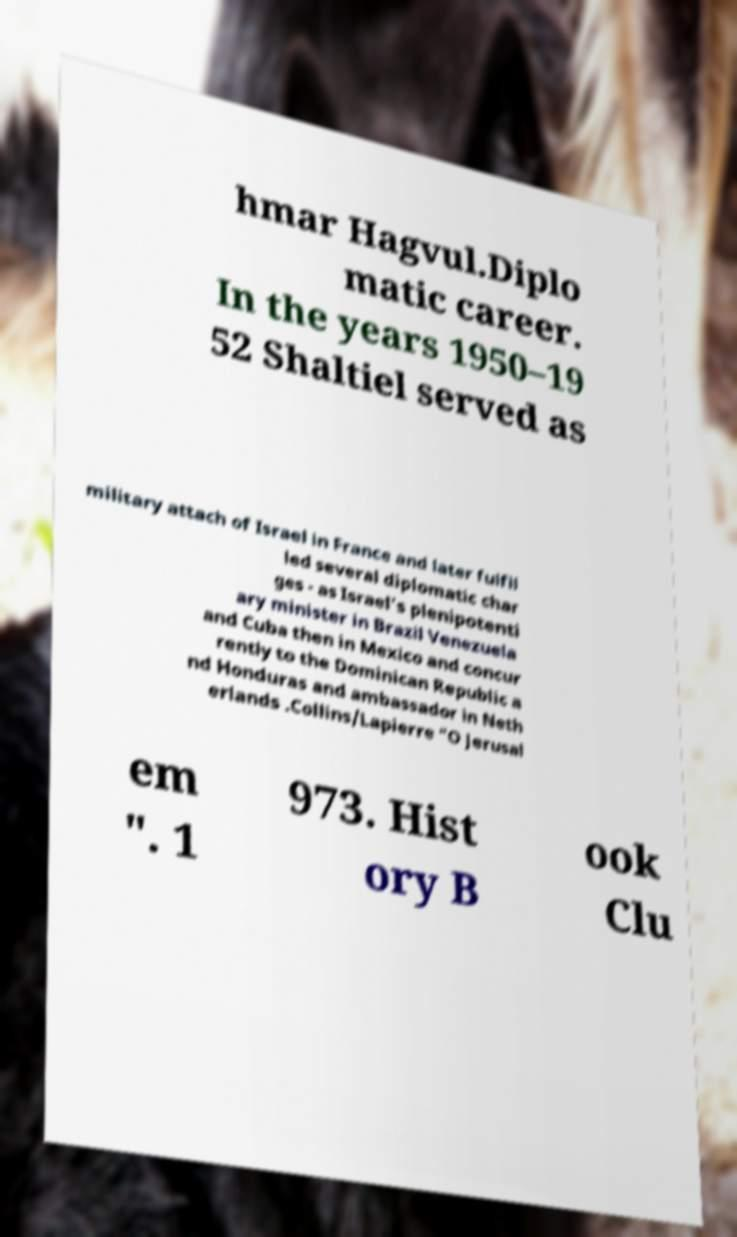For documentation purposes, I need the text within this image transcribed. Could you provide that? hmar Hagvul.Diplo matic career. In the years 1950–19 52 Shaltiel served as military attach of Israel in France and later fulfil led several diplomatic char ges - as Israel's plenipotenti ary minister in Brazil Venezuela and Cuba then in Mexico and concur rently to the Dominican Republic a nd Honduras and ambassador in Neth erlands .Collins/Lapierre "O Jerusal em ". 1 973. Hist ory B ook Clu 